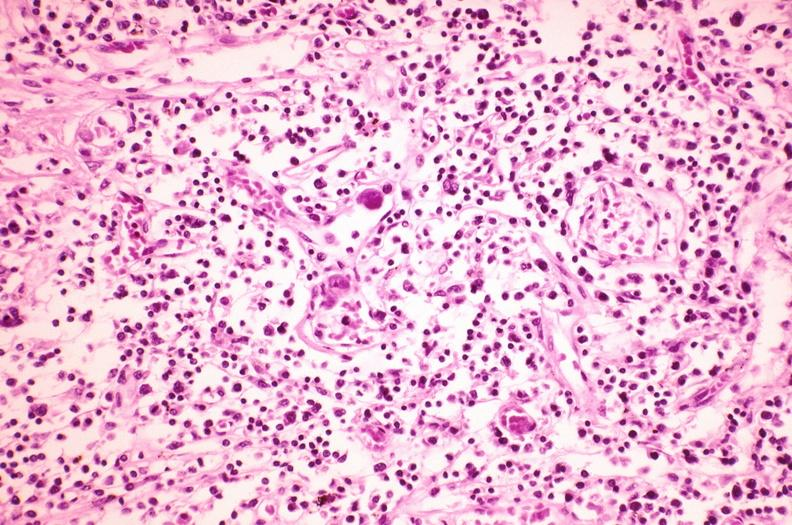does colon show lymph node, cytomegalovirus?
Answer the question using a single word or phrase. No 